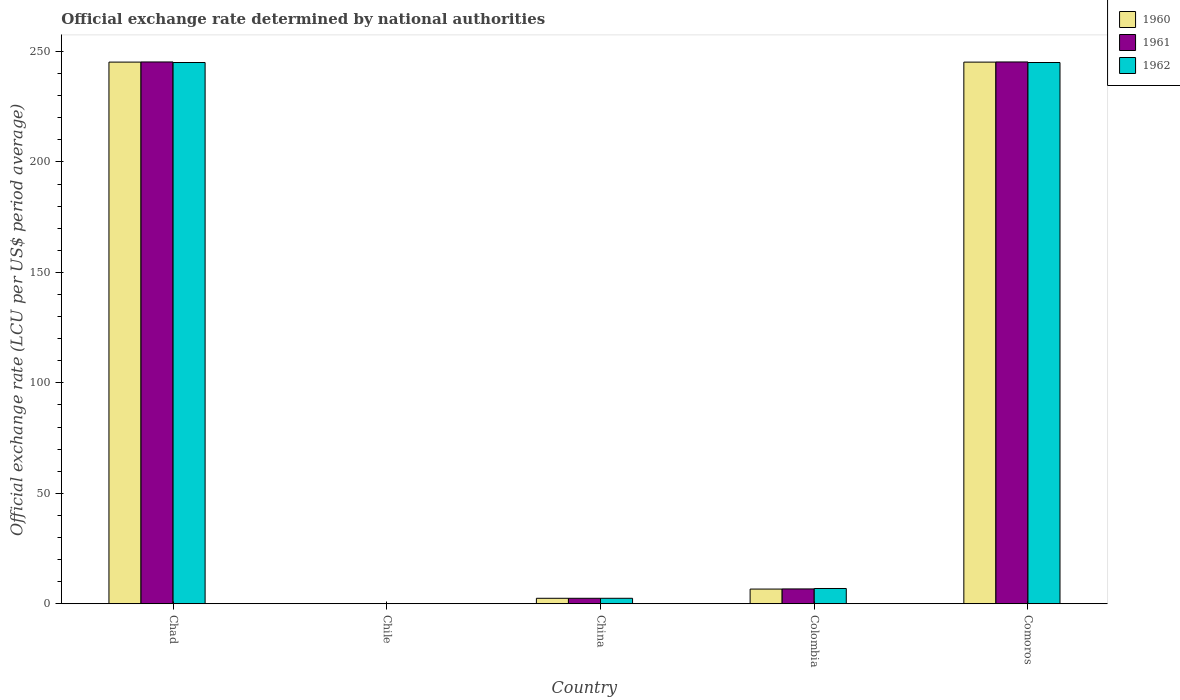How many groups of bars are there?
Provide a succinct answer. 5. Are the number of bars per tick equal to the number of legend labels?
Ensure brevity in your answer.  Yes. Are the number of bars on each tick of the X-axis equal?
Keep it short and to the point. Yes. How many bars are there on the 4th tick from the left?
Offer a very short reply. 3. How many bars are there on the 4th tick from the right?
Make the answer very short. 3. What is the label of the 5th group of bars from the left?
Make the answer very short. Comoros. In how many cases, is the number of bars for a given country not equal to the number of legend labels?
Keep it short and to the point. 0. What is the official exchange rate in 1962 in Colombia?
Give a very brief answer. 6.9. Across all countries, what is the maximum official exchange rate in 1960?
Provide a succinct answer. 245.2. Across all countries, what is the minimum official exchange rate in 1961?
Provide a succinct answer. 0. In which country was the official exchange rate in 1960 maximum?
Your answer should be very brief. Chad. In which country was the official exchange rate in 1960 minimum?
Your answer should be very brief. Chile. What is the total official exchange rate in 1960 in the graph?
Offer a very short reply. 499.49. What is the difference between the official exchange rate in 1960 in Chile and that in Comoros?
Give a very brief answer. -245.19. What is the difference between the official exchange rate in 1961 in Comoros and the official exchange rate in 1962 in China?
Make the answer very short. 242.8. What is the average official exchange rate in 1962 per country?
Provide a succinct answer. 99.88. What is the difference between the official exchange rate of/in 1961 and official exchange rate of/in 1962 in Chile?
Offer a terse response. -7.499781214689947e-6. What is the ratio of the official exchange rate in 1961 in Chad to that in China?
Offer a terse response. 99.63. What is the difference between the highest and the second highest official exchange rate in 1962?
Provide a short and direct response. -0. What is the difference between the highest and the lowest official exchange rate in 1960?
Offer a very short reply. 245.19. What does the 1st bar from the left in Colombia represents?
Your answer should be very brief. 1960. What does the 1st bar from the right in China represents?
Ensure brevity in your answer.  1962. Are all the bars in the graph horizontal?
Give a very brief answer. No. Does the graph contain grids?
Ensure brevity in your answer.  No. Where does the legend appear in the graph?
Offer a terse response. Top right. How many legend labels are there?
Provide a succinct answer. 3. How are the legend labels stacked?
Give a very brief answer. Vertical. What is the title of the graph?
Ensure brevity in your answer.  Official exchange rate determined by national authorities. What is the label or title of the X-axis?
Keep it short and to the point. Country. What is the label or title of the Y-axis?
Your answer should be very brief. Official exchange rate (LCU per US$ period average). What is the Official exchange rate (LCU per US$ period average) in 1960 in Chad?
Provide a succinct answer. 245.2. What is the Official exchange rate (LCU per US$ period average) of 1961 in Chad?
Offer a terse response. 245.26. What is the Official exchange rate (LCU per US$ period average) in 1962 in Chad?
Your answer should be compact. 245.01. What is the Official exchange rate (LCU per US$ period average) in 1960 in Chile?
Keep it short and to the point. 0. What is the Official exchange rate (LCU per US$ period average) in 1961 in Chile?
Make the answer very short. 0. What is the Official exchange rate (LCU per US$ period average) of 1962 in Chile?
Your response must be concise. 0. What is the Official exchange rate (LCU per US$ period average) of 1960 in China?
Provide a succinct answer. 2.46. What is the Official exchange rate (LCU per US$ period average) of 1961 in China?
Provide a short and direct response. 2.46. What is the Official exchange rate (LCU per US$ period average) of 1962 in China?
Offer a very short reply. 2.46. What is the Official exchange rate (LCU per US$ period average) of 1960 in Colombia?
Give a very brief answer. 6.63. What is the Official exchange rate (LCU per US$ period average) of 1961 in Colombia?
Give a very brief answer. 6.7. What is the Official exchange rate (LCU per US$ period average) in 1962 in Colombia?
Your answer should be very brief. 6.9. What is the Official exchange rate (LCU per US$ period average) in 1960 in Comoros?
Make the answer very short. 245.19. What is the Official exchange rate (LCU per US$ period average) of 1961 in Comoros?
Give a very brief answer. 245.26. What is the Official exchange rate (LCU per US$ period average) in 1962 in Comoros?
Provide a succinct answer. 245.01. Across all countries, what is the maximum Official exchange rate (LCU per US$ period average) in 1960?
Give a very brief answer. 245.2. Across all countries, what is the maximum Official exchange rate (LCU per US$ period average) in 1961?
Your answer should be very brief. 245.26. Across all countries, what is the maximum Official exchange rate (LCU per US$ period average) in 1962?
Provide a succinct answer. 245.01. Across all countries, what is the minimum Official exchange rate (LCU per US$ period average) of 1960?
Provide a succinct answer. 0. Across all countries, what is the minimum Official exchange rate (LCU per US$ period average) in 1961?
Ensure brevity in your answer.  0. Across all countries, what is the minimum Official exchange rate (LCU per US$ period average) in 1962?
Provide a succinct answer. 0. What is the total Official exchange rate (LCU per US$ period average) in 1960 in the graph?
Ensure brevity in your answer.  499.49. What is the total Official exchange rate (LCU per US$ period average) in 1961 in the graph?
Your answer should be very brief. 499.68. What is the total Official exchange rate (LCU per US$ period average) in 1962 in the graph?
Provide a succinct answer. 499.39. What is the difference between the Official exchange rate (LCU per US$ period average) in 1960 in Chad and that in Chile?
Ensure brevity in your answer.  245.19. What is the difference between the Official exchange rate (LCU per US$ period average) of 1961 in Chad and that in Chile?
Ensure brevity in your answer.  245.26. What is the difference between the Official exchange rate (LCU per US$ period average) of 1962 in Chad and that in Chile?
Provide a succinct answer. 245.01. What is the difference between the Official exchange rate (LCU per US$ period average) in 1960 in Chad and that in China?
Your response must be concise. 242.73. What is the difference between the Official exchange rate (LCU per US$ period average) in 1961 in Chad and that in China?
Offer a terse response. 242.8. What is the difference between the Official exchange rate (LCU per US$ period average) in 1962 in Chad and that in China?
Provide a short and direct response. 242.55. What is the difference between the Official exchange rate (LCU per US$ period average) in 1960 in Chad and that in Colombia?
Your answer should be very brief. 238.56. What is the difference between the Official exchange rate (LCU per US$ period average) in 1961 in Chad and that in Colombia?
Offer a very short reply. 238.56. What is the difference between the Official exchange rate (LCU per US$ period average) in 1962 in Chad and that in Colombia?
Keep it short and to the point. 238.11. What is the difference between the Official exchange rate (LCU per US$ period average) in 1960 in Chad and that in Comoros?
Offer a very short reply. 0. What is the difference between the Official exchange rate (LCU per US$ period average) in 1961 in Chad and that in Comoros?
Provide a short and direct response. 0. What is the difference between the Official exchange rate (LCU per US$ period average) in 1962 in Chad and that in Comoros?
Ensure brevity in your answer.  0. What is the difference between the Official exchange rate (LCU per US$ period average) of 1960 in Chile and that in China?
Provide a short and direct response. -2.46. What is the difference between the Official exchange rate (LCU per US$ period average) of 1961 in Chile and that in China?
Provide a short and direct response. -2.46. What is the difference between the Official exchange rate (LCU per US$ period average) of 1962 in Chile and that in China?
Your response must be concise. -2.46. What is the difference between the Official exchange rate (LCU per US$ period average) in 1960 in Chile and that in Colombia?
Ensure brevity in your answer.  -6.63. What is the difference between the Official exchange rate (LCU per US$ period average) in 1961 in Chile and that in Colombia?
Your answer should be very brief. -6.7. What is the difference between the Official exchange rate (LCU per US$ period average) in 1962 in Chile and that in Colombia?
Keep it short and to the point. -6.9. What is the difference between the Official exchange rate (LCU per US$ period average) in 1960 in Chile and that in Comoros?
Ensure brevity in your answer.  -245.19. What is the difference between the Official exchange rate (LCU per US$ period average) in 1961 in Chile and that in Comoros?
Your answer should be very brief. -245.26. What is the difference between the Official exchange rate (LCU per US$ period average) in 1962 in Chile and that in Comoros?
Your answer should be very brief. -245.01. What is the difference between the Official exchange rate (LCU per US$ period average) in 1960 in China and that in Colombia?
Make the answer very short. -4.17. What is the difference between the Official exchange rate (LCU per US$ period average) in 1961 in China and that in Colombia?
Give a very brief answer. -4.24. What is the difference between the Official exchange rate (LCU per US$ period average) of 1962 in China and that in Colombia?
Your response must be concise. -4.44. What is the difference between the Official exchange rate (LCU per US$ period average) in 1960 in China and that in Comoros?
Keep it short and to the point. -242.73. What is the difference between the Official exchange rate (LCU per US$ period average) in 1961 in China and that in Comoros?
Provide a succinct answer. -242.8. What is the difference between the Official exchange rate (LCU per US$ period average) in 1962 in China and that in Comoros?
Provide a short and direct response. -242.55. What is the difference between the Official exchange rate (LCU per US$ period average) in 1960 in Colombia and that in Comoros?
Your answer should be compact. -238.56. What is the difference between the Official exchange rate (LCU per US$ period average) of 1961 in Colombia and that in Comoros?
Your answer should be compact. -238.56. What is the difference between the Official exchange rate (LCU per US$ period average) of 1962 in Colombia and that in Comoros?
Keep it short and to the point. -238.11. What is the difference between the Official exchange rate (LCU per US$ period average) in 1960 in Chad and the Official exchange rate (LCU per US$ period average) in 1961 in Chile?
Offer a terse response. 245.19. What is the difference between the Official exchange rate (LCU per US$ period average) of 1960 in Chad and the Official exchange rate (LCU per US$ period average) of 1962 in Chile?
Keep it short and to the point. 245.19. What is the difference between the Official exchange rate (LCU per US$ period average) of 1961 in Chad and the Official exchange rate (LCU per US$ period average) of 1962 in Chile?
Offer a very short reply. 245.26. What is the difference between the Official exchange rate (LCU per US$ period average) of 1960 in Chad and the Official exchange rate (LCU per US$ period average) of 1961 in China?
Give a very brief answer. 242.73. What is the difference between the Official exchange rate (LCU per US$ period average) of 1960 in Chad and the Official exchange rate (LCU per US$ period average) of 1962 in China?
Offer a terse response. 242.73. What is the difference between the Official exchange rate (LCU per US$ period average) of 1961 in Chad and the Official exchange rate (LCU per US$ period average) of 1962 in China?
Your answer should be compact. 242.8. What is the difference between the Official exchange rate (LCU per US$ period average) in 1960 in Chad and the Official exchange rate (LCU per US$ period average) in 1961 in Colombia?
Your response must be concise. 238.5. What is the difference between the Official exchange rate (LCU per US$ period average) in 1960 in Chad and the Official exchange rate (LCU per US$ period average) in 1962 in Colombia?
Offer a very short reply. 238.29. What is the difference between the Official exchange rate (LCU per US$ period average) of 1961 in Chad and the Official exchange rate (LCU per US$ period average) of 1962 in Colombia?
Ensure brevity in your answer.  238.36. What is the difference between the Official exchange rate (LCU per US$ period average) in 1960 in Chad and the Official exchange rate (LCU per US$ period average) in 1961 in Comoros?
Your response must be concise. -0.06. What is the difference between the Official exchange rate (LCU per US$ period average) of 1960 in Chad and the Official exchange rate (LCU per US$ period average) of 1962 in Comoros?
Make the answer very short. 0.18. What is the difference between the Official exchange rate (LCU per US$ period average) in 1961 in Chad and the Official exchange rate (LCU per US$ period average) in 1962 in Comoros?
Make the answer very short. 0.25. What is the difference between the Official exchange rate (LCU per US$ period average) of 1960 in Chile and the Official exchange rate (LCU per US$ period average) of 1961 in China?
Your answer should be very brief. -2.46. What is the difference between the Official exchange rate (LCU per US$ period average) in 1960 in Chile and the Official exchange rate (LCU per US$ period average) in 1962 in China?
Provide a short and direct response. -2.46. What is the difference between the Official exchange rate (LCU per US$ period average) in 1961 in Chile and the Official exchange rate (LCU per US$ period average) in 1962 in China?
Your answer should be very brief. -2.46. What is the difference between the Official exchange rate (LCU per US$ period average) of 1960 in Chile and the Official exchange rate (LCU per US$ period average) of 1961 in Colombia?
Ensure brevity in your answer.  -6.7. What is the difference between the Official exchange rate (LCU per US$ period average) in 1960 in Chile and the Official exchange rate (LCU per US$ period average) in 1962 in Colombia?
Your response must be concise. -6.9. What is the difference between the Official exchange rate (LCU per US$ period average) in 1961 in Chile and the Official exchange rate (LCU per US$ period average) in 1962 in Colombia?
Keep it short and to the point. -6.9. What is the difference between the Official exchange rate (LCU per US$ period average) of 1960 in Chile and the Official exchange rate (LCU per US$ period average) of 1961 in Comoros?
Provide a succinct answer. -245.26. What is the difference between the Official exchange rate (LCU per US$ period average) of 1960 in Chile and the Official exchange rate (LCU per US$ period average) of 1962 in Comoros?
Your response must be concise. -245.01. What is the difference between the Official exchange rate (LCU per US$ period average) in 1961 in Chile and the Official exchange rate (LCU per US$ period average) in 1962 in Comoros?
Provide a short and direct response. -245.01. What is the difference between the Official exchange rate (LCU per US$ period average) in 1960 in China and the Official exchange rate (LCU per US$ period average) in 1961 in Colombia?
Offer a terse response. -4.24. What is the difference between the Official exchange rate (LCU per US$ period average) in 1960 in China and the Official exchange rate (LCU per US$ period average) in 1962 in Colombia?
Ensure brevity in your answer.  -4.44. What is the difference between the Official exchange rate (LCU per US$ period average) of 1961 in China and the Official exchange rate (LCU per US$ period average) of 1962 in Colombia?
Ensure brevity in your answer.  -4.44. What is the difference between the Official exchange rate (LCU per US$ period average) in 1960 in China and the Official exchange rate (LCU per US$ period average) in 1961 in Comoros?
Offer a terse response. -242.8. What is the difference between the Official exchange rate (LCU per US$ period average) in 1960 in China and the Official exchange rate (LCU per US$ period average) in 1962 in Comoros?
Offer a very short reply. -242.55. What is the difference between the Official exchange rate (LCU per US$ period average) in 1961 in China and the Official exchange rate (LCU per US$ period average) in 1962 in Comoros?
Make the answer very short. -242.55. What is the difference between the Official exchange rate (LCU per US$ period average) of 1960 in Colombia and the Official exchange rate (LCU per US$ period average) of 1961 in Comoros?
Provide a short and direct response. -238.62. What is the difference between the Official exchange rate (LCU per US$ period average) in 1960 in Colombia and the Official exchange rate (LCU per US$ period average) in 1962 in Comoros?
Keep it short and to the point. -238.38. What is the difference between the Official exchange rate (LCU per US$ period average) in 1961 in Colombia and the Official exchange rate (LCU per US$ period average) in 1962 in Comoros?
Provide a succinct answer. -238.31. What is the average Official exchange rate (LCU per US$ period average) of 1960 per country?
Offer a terse response. 99.9. What is the average Official exchange rate (LCU per US$ period average) in 1961 per country?
Your answer should be compact. 99.94. What is the average Official exchange rate (LCU per US$ period average) of 1962 per country?
Keep it short and to the point. 99.88. What is the difference between the Official exchange rate (LCU per US$ period average) of 1960 and Official exchange rate (LCU per US$ period average) of 1961 in Chad?
Keep it short and to the point. -0.07. What is the difference between the Official exchange rate (LCU per US$ period average) of 1960 and Official exchange rate (LCU per US$ period average) of 1962 in Chad?
Your answer should be compact. 0.18. What is the difference between the Official exchange rate (LCU per US$ period average) of 1961 and Official exchange rate (LCU per US$ period average) of 1962 in Chad?
Your answer should be very brief. 0.25. What is the difference between the Official exchange rate (LCU per US$ period average) of 1960 and Official exchange rate (LCU per US$ period average) of 1961 in Chile?
Keep it short and to the point. -0. What is the difference between the Official exchange rate (LCU per US$ period average) in 1960 and Official exchange rate (LCU per US$ period average) in 1962 in Chile?
Make the answer very short. -0. What is the difference between the Official exchange rate (LCU per US$ period average) of 1960 and Official exchange rate (LCU per US$ period average) of 1962 in China?
Your answer should be very brief. 0. What is the difference between the Official exchange rate (LCU per US$ period average) of 1961 and Official exchange rate (LCU per US$ period average) of 1962 in China?
Your response must be concise. 0. What is the difference between the Official exchange rate (LCU per US$ period average) in 1960 and Official exchange rate (LCU per US$ period average) in 1961 in Colombia?
Your answer should be compact. -0.07. What is the difference between the Official exchange rate (LCU per US$ period average) in 1960 and Official exchange rate (LCU per US$ period average) in 1962 in Colombia?
Provide a succinct answer. -0.27. What is the difference between the Official exchange rate (LCU per US$ period average) of 1961 and Official exchange rate (LCU per US$ period average) of 1962 in Colombia?
Offer a very short reply. -0.2. What is the difference between the Official exchange rate (LCU per US$ period average) of 1960 and Official exchange rate (LCU per US$ period average) of 1961 in Comoros?
Your answer should be very brief. -0.07. What is the difference between the Official exchange rate (LCU per US$ period average) of 1960 and Official exchange rate (LCU per US$ period average) of 1962 in Comoros?
Offer a very short reply. 0.18. What is the difference between the Official exchange rate (LCU per US$ period average) in 1961 and Official exchange rate (LCU per US$ period average) in 1962 in Comoros?
Your answer should be very brief. 0.25. What is the ratio of the Official exchange rate (LCU per US$ period average) in 1960 in Chad to that in Chile?
Offer a terse response. 2.34e+05. What is the ratio of the Official exchange rate (LCU per US$ period average) in 1961 in Chad to that in Chile?
Make the answer very short. 2.34e+05. What is the ratio of the Official exchange rate (LCU per US$ period average) of 1962 in Chad to that in Chile?
Provide a succinct answer. 2.32e+05. What is the ratio of the Official exchange rate (LCU per US$ period average) of 1960 in Chad to that in China?
Provide a short and direct response. 99.6. What is the ratio of the Official exchange rate (LCU per US$ period average) in 1961 in Chad to that in China?
Make the answer very short. 99.63. What is the ratio of the Official exchange rate (LCU per US$ period average) in 1962 in Chad to that in China?
Your answer should be very brief. 99.53. What is the ratio of the Official exchange rate (LCU per US$ period average) of 1960 in Chad to that in Colombia?
Offer a very short reply. 36.95. What is the ratio of the Official exchange rate (LCU per US$ period average) of 1961 in Chad to that in Colombia?
Provide a short and direct response. 36.61. What is the ratio of the Official exchange rate (LCU per US$ period average) of 1962 in Chad to that in Colombia?
Your answer should be very brief. 35.5. What is the ratio of the Official exchange rate (LCU per US$ period average) of 1960 in Chad to that in Comoros?
Your answer should be compact. 1. What is the ratio of the Official exchange rate (LCU per US$ period average) in 1962 in Chad to that in Comoros?
Provide a succinct answer. 1. What is the ratio of the Official exchange rate (LCU per US$ period average) of 1960 in Chile to that in China?
Offer a very short reply. 0. What is the ratio of the Official exchange rate (LCU per US$ period average) of 1962 in Chile to that in China?
Keep it short and to the point. 0. What is the ratio of the Official exchange rate (LCU per US$ period average) of 1960 in Chile to that in Colombia?
Your answer should be compact. 0. What is the ratio of the Official exchange rate (LCU per US$ period average) in 1961 in Chile to that in Colombia?
Your answer should be very brief. 0. What is the ratio of the Official exchange rate (LCU per US$ period average) of 1960 in Chile to that in Comoros?
Your answer should be very brief. 0. What is the ratio of the Official exchange rate (LCU per US$ period average) in 1960 in China to that in Colombia?
Make the answer very short. 0.37. What is the ratio of the Official exchange rate (LCU per US$ period average) in 1961 in China to that in Colombia?
Your answer should be compact. 0.37. What is the ratio of the Official exchange rate (LCU per US$ period average) of 1962 in China to that in Colombia?
Provide a short and direct response. 0.36. What is the ratio of the Official exchange rate (LCU per US$ period average) of 1961 in China to that in Comoros?
Your response must be concise. 0.01. What is the ratio of the Official exchange rate (LCU per US$ period average) of 1960 in Colombia to that in Comoros?
Provide a short and direct response. 0.03. What is the ratio of the Official exchange rate (LCU per US$ period average) in 1961 in Colombia to that in Comoros?
Make the answer very short. 0.03. What is the ratio of the Official exchange rate (LCU per US$ period average) of 1962 in Colombia to that in Comoros?
Provide a succinct answer. 0.03. What is the difference between the highest and the second highest Official exchange rate (LCU per US$ period average) of 1960?
Give a very brief answer. 0. What is the difference between the highest and the second highest Official exchange rate (LCU per US$ period average) in 1961?
Your answer should be compact. 0. What is the difference between the highest and the second highest Official exchange rate (LCU per US$ period average) in 1962?
Make the answer very short. 0. What is the difference between the highest and the lowest Official exchange rate (LCU per US$ period average) of 1960?
Your response must be concise. 245.19. What is the difference between the highest and the lowest Official exchange rate (LCU per US$ period average) in 1961?
Keep it short and to the point. 245.26. What is the difference between the highest and the lowest Official exchange rate (LCU per US$ period average) of 1962?
Your answer should be very brief. 245.01. 